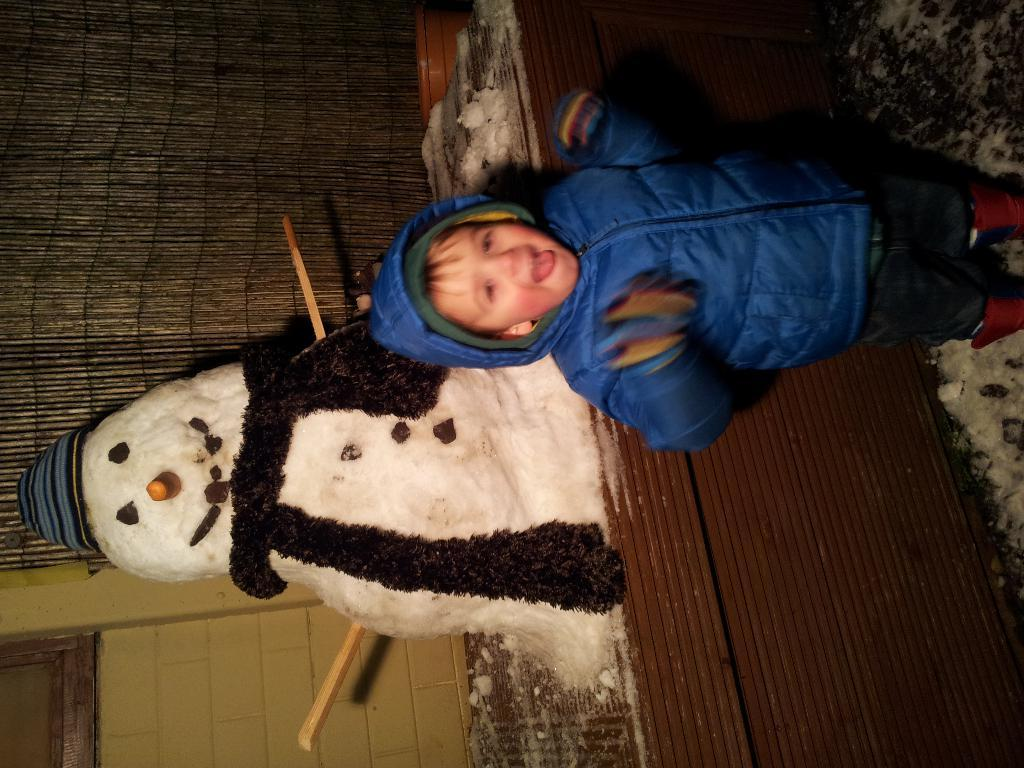What is the main subject in the foreground of the image? There is a boy standing in the foreground of the image. What is located behind the boy in the image? There is a snowman behind the boy. What type of structure can be seen in the image? There is a wall visible in the image. What type of window treatment is present in the image? There is a curtain in the image. How many kittens are playing with the curtain in the image? There are no kittens present in the image, so it is not possible to determine how many might be playing with the curtain. 